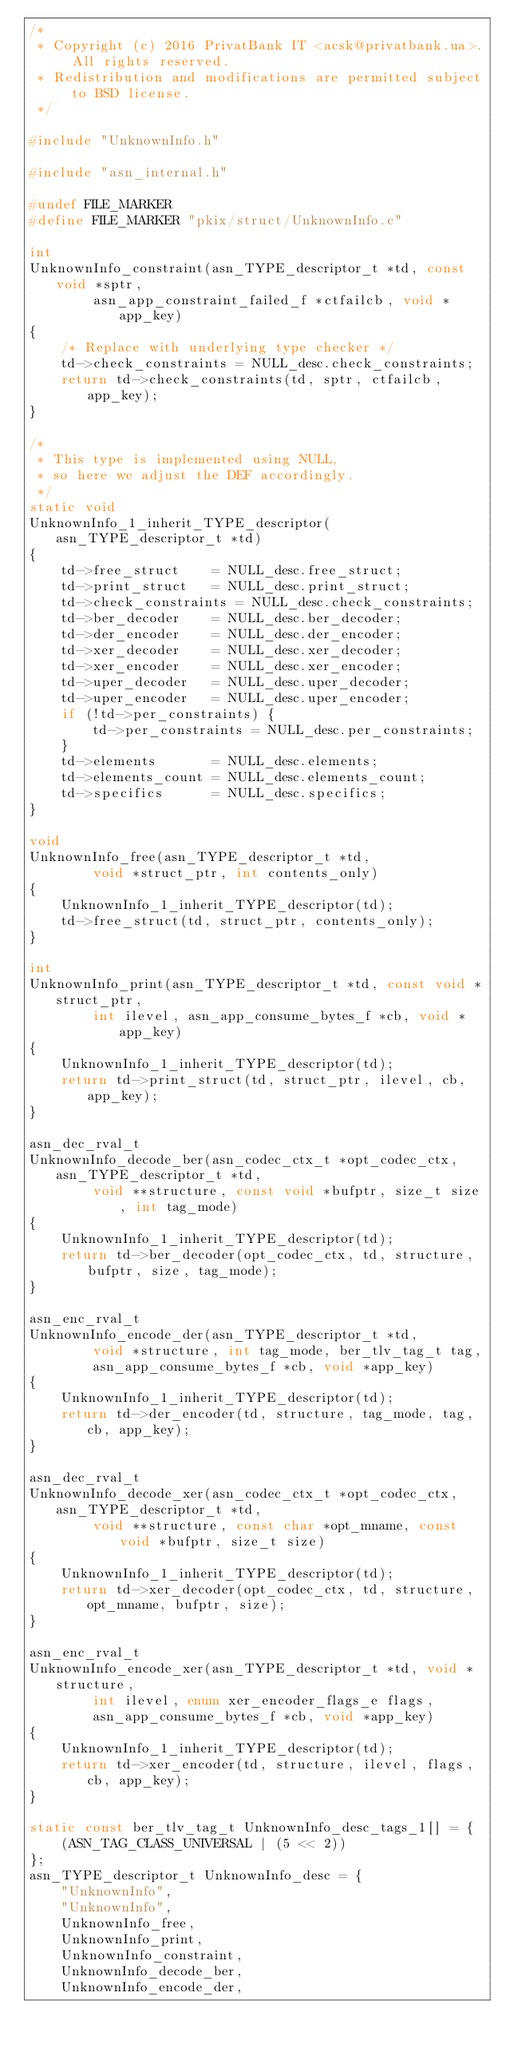Convert code to text. <code><loc_0><loc_0><loc_500><loc_500><_C_>/*
 * Copyright (c) 2016 PrivatBank IT <acsk@privatbank.ua>. All rights reserved.
 * Redistribution and modifications are permitted subject to BSD license.
 */

#include "UnknownInfo.h"

#include "asn_internal.h"

#undef FILE_MARKER
#define FILE_MARKER "pkix/struct/UnknownInfo.c"

int
UnknownInfo_constraint(asn_TYPE_descriptor_t *td, const void *sptr,
        asn_app_constraint_failed_f *ctfailcb, void *app_key)
{
    /* Replace with underlying type checker */
    td->check_constraints = NULL_desc.check_constraints;
    return td->check_constraints(td, sptr, ctfailcb, app_key);
}

/*
 * This type is implemented using NULL,
 * so here we adjust the DEF accordingly.
 */
static void
UnknownInfo_1_inherit_TYPE_descriptor(asn_TYPE_descriptor_t *td)
{
    td->free_struct    = NULL_desc.free_struct;
    td->print_struct   = NULL_desc.print_struct;
    td->check_constraints = NULL_desc.check_constraints;
    td->ber_decoder    = NULL_desc.ber_decoder;
    td->der_encoder    = NULL_desc.der_encoder;
    td->xer_decoder    = NULL_desc.xer_decoder;
    td->xer_encoder    = NULL_desc.xer_encoder;
    td->uper_decoder   = NULL_desc.uper_decoder;
    td->uper_encoder   = NULL_desc.uper_encoder;
    if (!td->per_constraints) {
        td->per_constraints = NULL_desc.per_constraints;
    }
    td->elements       = NULL_desc.elements;
    td->elements_count = NULL_desc.elements_count;
    td->specifics      = NULL_desc.specifics;
}

void
UnknownInfo_free(asn_TYPE_descriptor_t *td,
        void *struct_ptr, int contents_only)
{
    UnknownInfo_1_inherit_TYPE_descriptor(td);
    td->free_struct(td, struct_ptr, contents_only);
}

int
UnknownInfo_print(asn_TYPE_descriptor_t *td, const void *struct_ptr,
        int ilevel, asn_app_consume_bytes_f *cb, void *app_key)
{
    UnknownInfo_1_inherit_TYPE_descriptor(td);
    return td->print_struct(td, struct_ptr, ilevel, cb, app_key);
}

asn_dec_rval_t
UnknownInfo_decode_ber(asn_codec_ctx_t *opt_codec_ctx, asn_TYPE_descriptor_t *td,
        void **structure, const void *bufptr, size_t size, int tag_mode)
{
    UnknownInfo_1_inherit_TYPE_descriptor(td);
    return td->ber_decoder(opt_codec_ctx, td, structure, bufptr, size, tag_mode);
}

asn_enc_rval_t
UnknownInfo_encode_der(asn_TYPE_descriptor_t *td,
        void *structure, int tag_mode, ber_tlv_tag_t tag,
        asn_app_consume_bytes_f *cb, void *app_key)
{
    UnknownInfo_1_inherit_TYPE_descriptor(td);
    return td->der_encoder(td, structure, tag_mode, tag, cb, app_key);
}

asn_dec_rval_t
UnknownInfo_decode_xer(asn_codec_ctx_t *opt_codec_ctx, asn_TYPE_descriptor_t *td,
        void **structure, const char *opt_mname, const void *bufptr, size_t size)
{
    UnknownInfo_1_inherit_TYPE_descriptor(td);
    return td->xer_decoder(opt_codec_ctx, td, structure, opt_mname, bufptr, size);
}

asn_enc_rval_t
UnknownInfo_encode_xer(asn_TYPE_descriptor_t *td, void *structure,
        int ilevel, enum xer_encoder_flags_e flags,
        asn_app_consume_bytes_f *cb, void *app_key)
{
    UnknownInfo_1_inherit_TYPE_descriptor(td);
    return td->xer_encoder(td, structure, ilevel, flags, cb, app_key);
}

static const ber_tlv_tag_t UnknownInfo_desc_tags_1[] = {
    (ASN_TAG_CLASS_UNIVERSAL | (5 << 2))
};
asn_TYPE_descriptor_t UnknownInfo_desc = {
    "UnknownInfo",
    "UnknownInfo",
    UnknownInfo_free,
    UnknownInfo_print,
    UnknownInfo_constraint,
    UnknownInfo_decode_ber,
    UnknownInfo_encode_der,</code> 